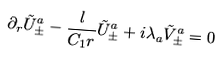Convert formula to latex. <formula><loc_0><loc_0><loc_500><loc_500>\partial _ { r } \tilde { U } ^ { a } _ { \pm } - \frac { l } { C _ { 1 } r } \tilde { U } ^ { a } _ { \pm } + i \lambda _ { a } \tilde { V } ^ { a } _ { \pm } = 0</formula> 